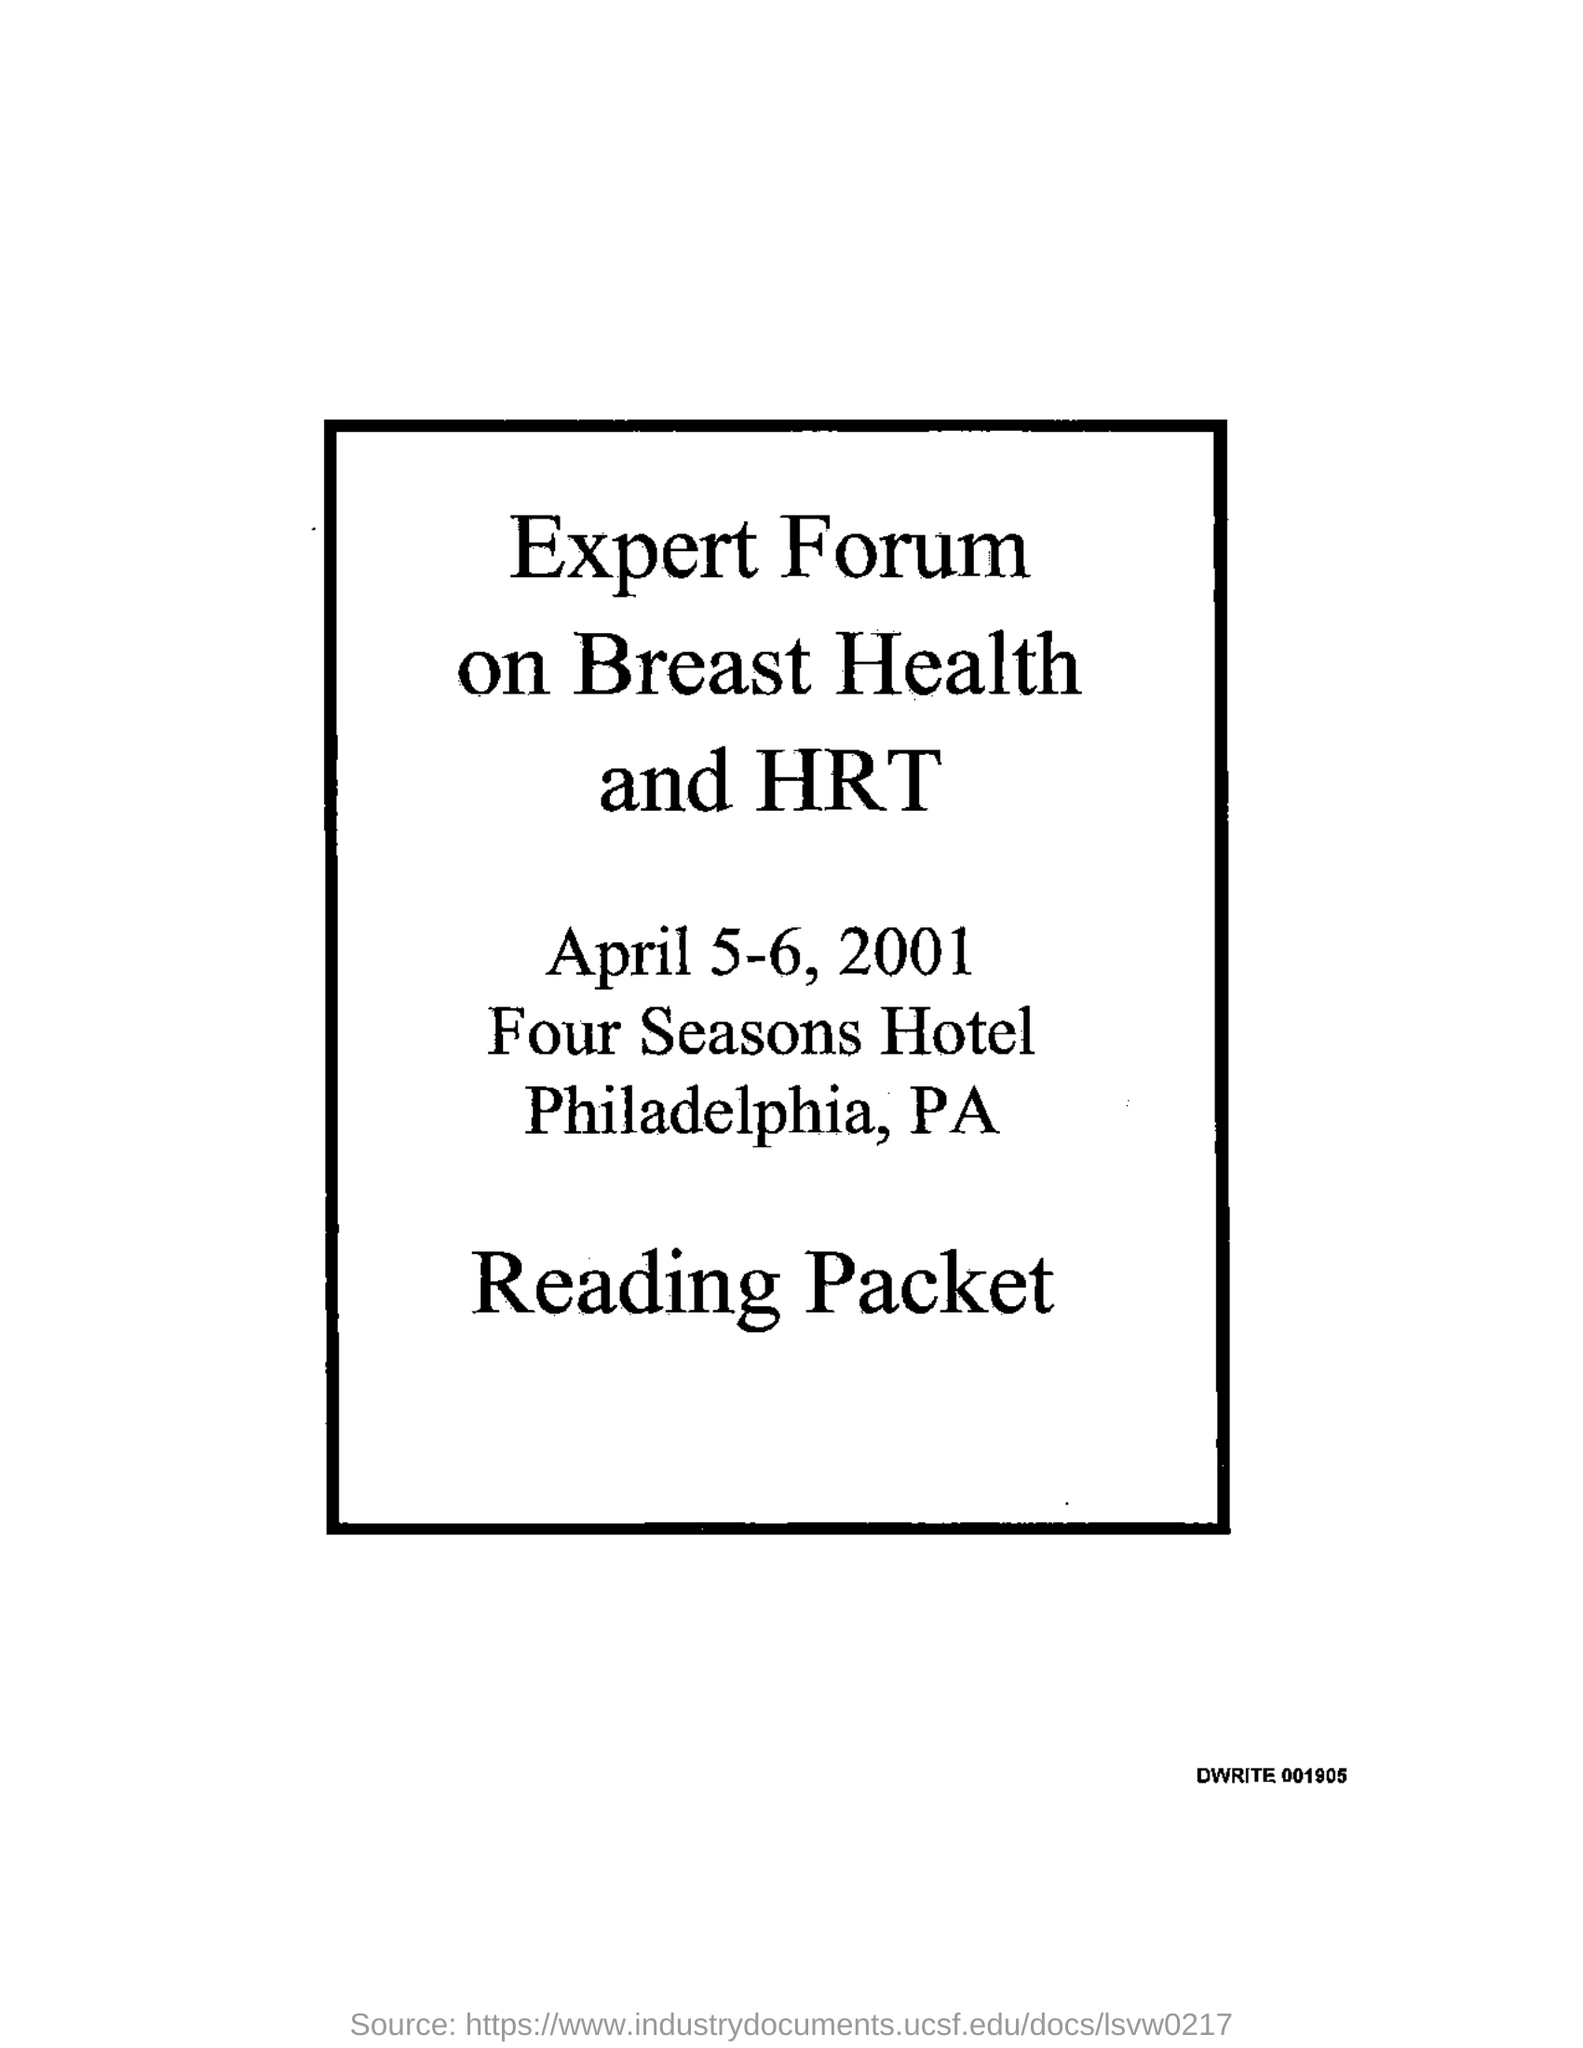Give some essential details in this illustration. The Expert Forum on Breast Health and HRT will be held on April 5-6, 2001. 